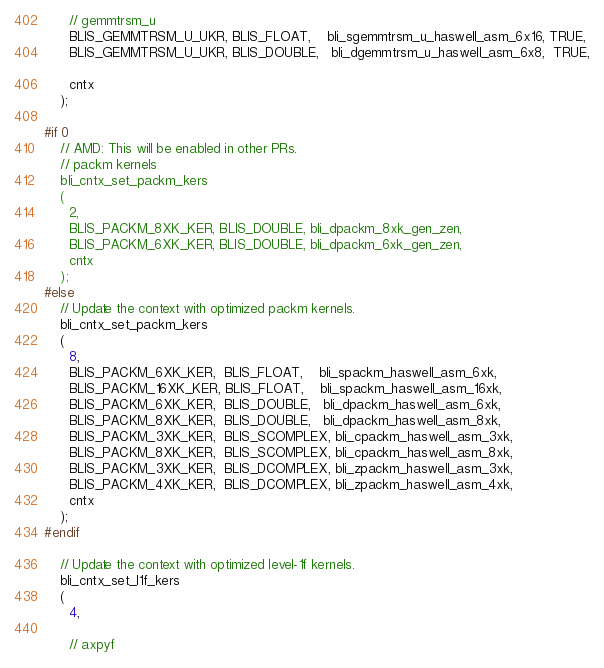Convert code to text. <code><loc_0><loc_0><loc_500><loc_500><_C_>
	  // gemmtrsm_u
	  BLIS_GEMMTRSM_U_UKR, BLIS_FLOAT,    bli_sgemmtrsm_u_haswell_asm_6x16, TRUE,
	  BLIS_GEMMTRSM_U_UKR, BLIS_DOUBLE,   bli_dgemmtrsm_u_haswell_asm_6x8,  TRUE,

	  cntx
	);

#if 0
	// AMD: This will be enabled in other PRs.
	// packm kernels
	bli_cntx_set_packm_kers
	(
	  2,
	  BLIS_PACKM_8XK_KER, BLIS_DOUBLE, bli_dpackm_8xk_gen_zen,
	  BLIS_PACKM_6XK_KER, BLIS_DOUBLE, bli_dpackm_6xk_gen_zen,
	  cntx
	);
#else
	// Update the context with optimized packm kernels.
	bli_cntx_set_packm_kers
	(
	  8,
	  BLIS_PACKM_6XK_KER,  BLIS_FLOAT,    bli_spackm_haswell_asm_6xk,
	  BLIS_PACKM_16XK_KER, BLIS_FLOAT,    bli_spackm_haswell_asm_16xk,
	  BLIS_PACKM_6XK_KER,  BLIS_DOUBLE,   bli_dpackm_haswell_asm_6xk,
	  BLIS_PACKM_8XK_KER,  BLIS_DOUBLE,   bli_dpackm_haswell_asm_8xk,
	  BLIS_PACKM_3XK_KER,  BLIS_SCOMPLEX, bli_cpackm_haswell_asm_3xk,
	  BLIS_PACKM_8XK_KER,  BLIS_SCOMPLEX, bli_cpackm_haswell_asm_8xk,
	  BLIS_PACKM_3XK_KER,  BLIS_DCOMPLEX, bli_zpackm_haswell_asm_3xk,
	  BLIS_PACKM_4XK_KER,  BLIS_DCOMPLEX, bli_zpackm_haswell_asm_4xk,
	  cntx
	);
#endif

	// Update the context with optimized level-1f kernels.
	bli_cntx_set_l1f_kers
	(
	  4,

	  // axpyf</code> 